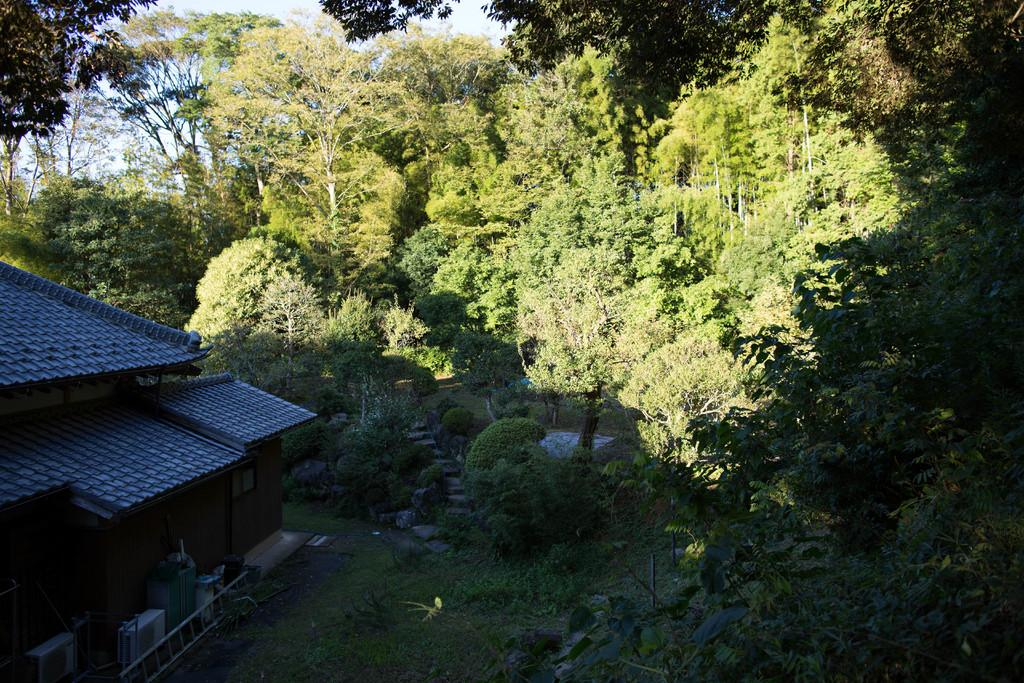What type of structure is visible in the image? There is a house in the image. What object can be seen near the house? There is a ladder in the image. What type of vegetation is present in the image? There is grass and trees in the image. What type of ground surface is visible in the image? There are stones in the image. What else can be seen in the image besides the house, ladder, grass, trees, and stones? There are some objects in the image. What is visible in the background of the image? The sky is visible in the background of the image. Can you tell me how many ducks are swimming in the pond in the image? There is no pond or duck present in the image. What type of locket is the parent wearing in the image? There is no parent or locket present in the image. 